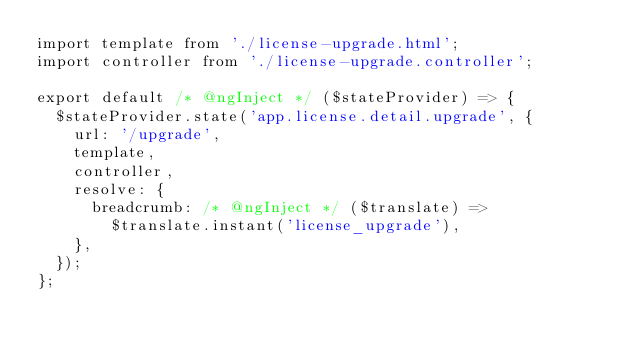<code> <loc_0><loc_0><loc_500><loc_500><_JavaScript_>import template from './license-upgrade.html';
import controller from './license-upgrade.controller';

export default /* @ngInject */ ($stateProvider) => {
  $stateProvider.state('app.license.detail.upgrade', {
    url: '/upgrade',
    template,
    controller,
    resolve: {
      breadcrumb: /* @ngInject */ ($translate) =>
        $translate.instant('license_upgrade'),
    },
  });
};
</code> 